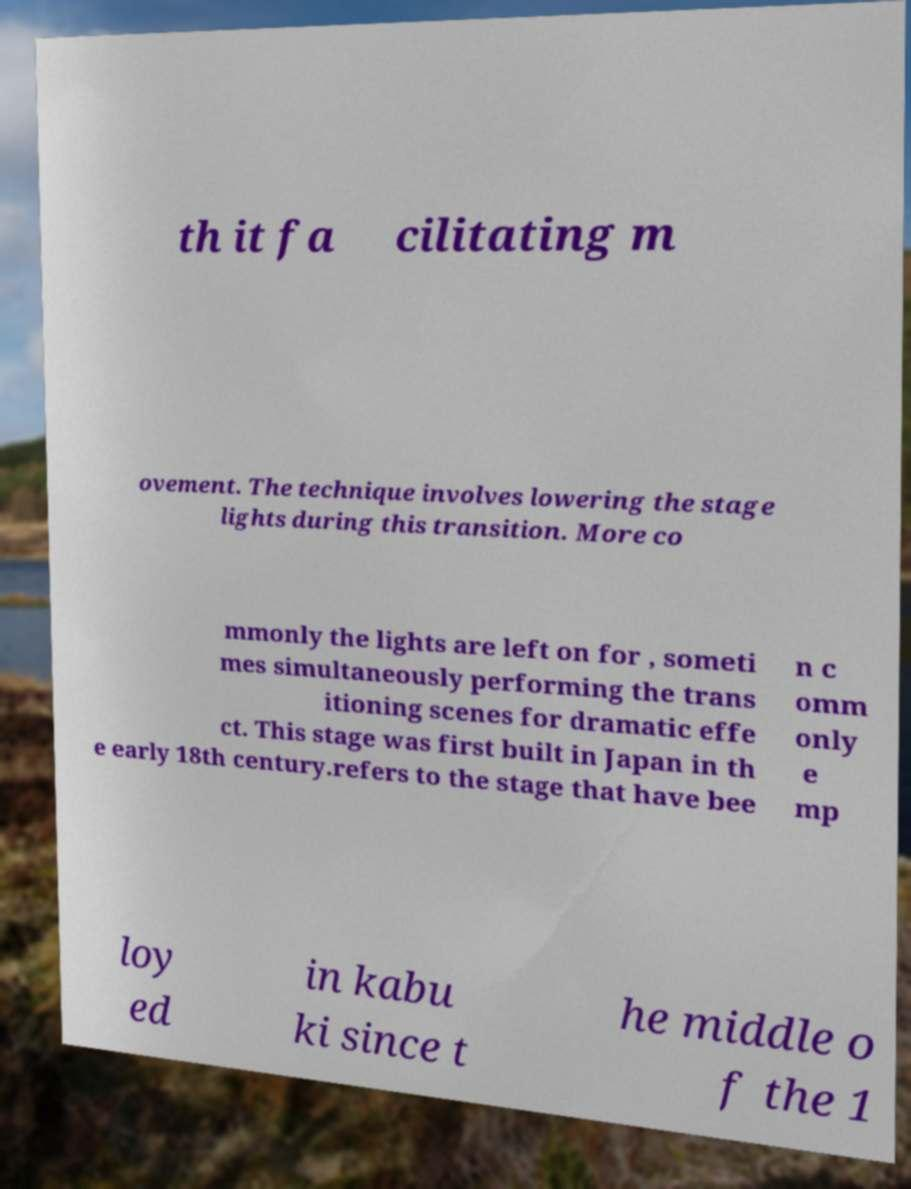I need the written content from this picture converted into text. Can you do that? th it fa cilitating m ovement. The technique involves lowering the stage lights during this transition. More co mmonly the lights are left on for , someti mes simultaneously performing the trans itioning scenes for dramatic effe ct. This stage was first built in Japan in th e early 18th century.refers to the stage that have bee n c omm only e mp loy ed in kabu ki since t he middle o f the 1 